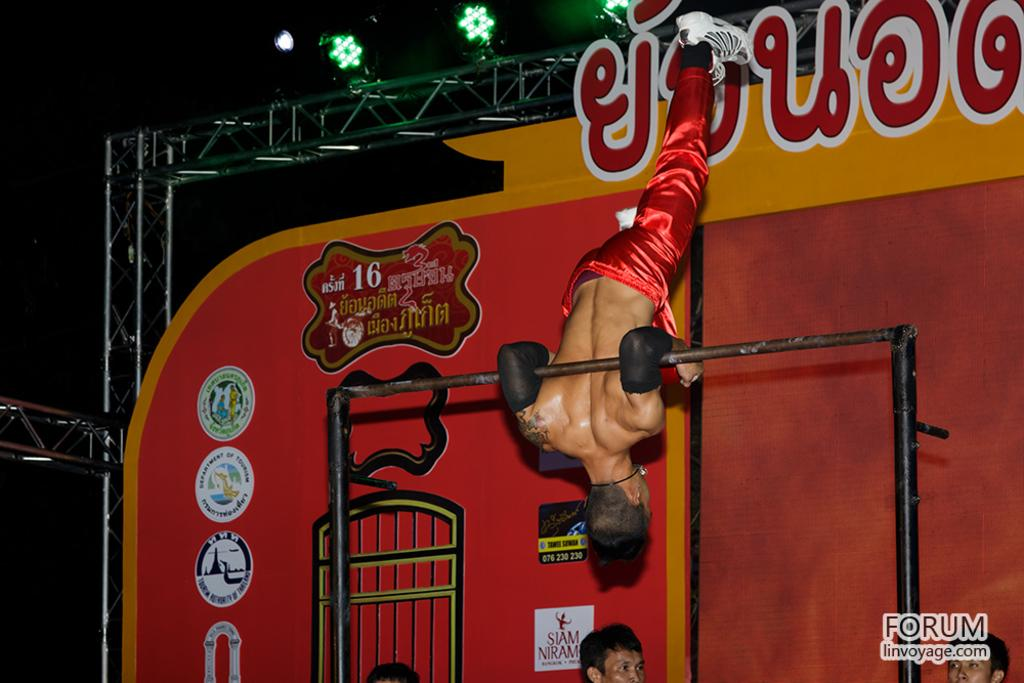What is the man in the image holding? The man is holding a pole in the image. Can you describe the other people in the image? There are people in the image, but their specific actions or features are not mentioned in the provided facts. What can be seen in the background of the image? There are lights visible in the background of the image. How would you describe the overall lighting in the image? The image appears to be set in a dark environment. What type of sheet is draped over the man's horn in the image? There is no sheet or horn present in the image; the man is holding a pole. 